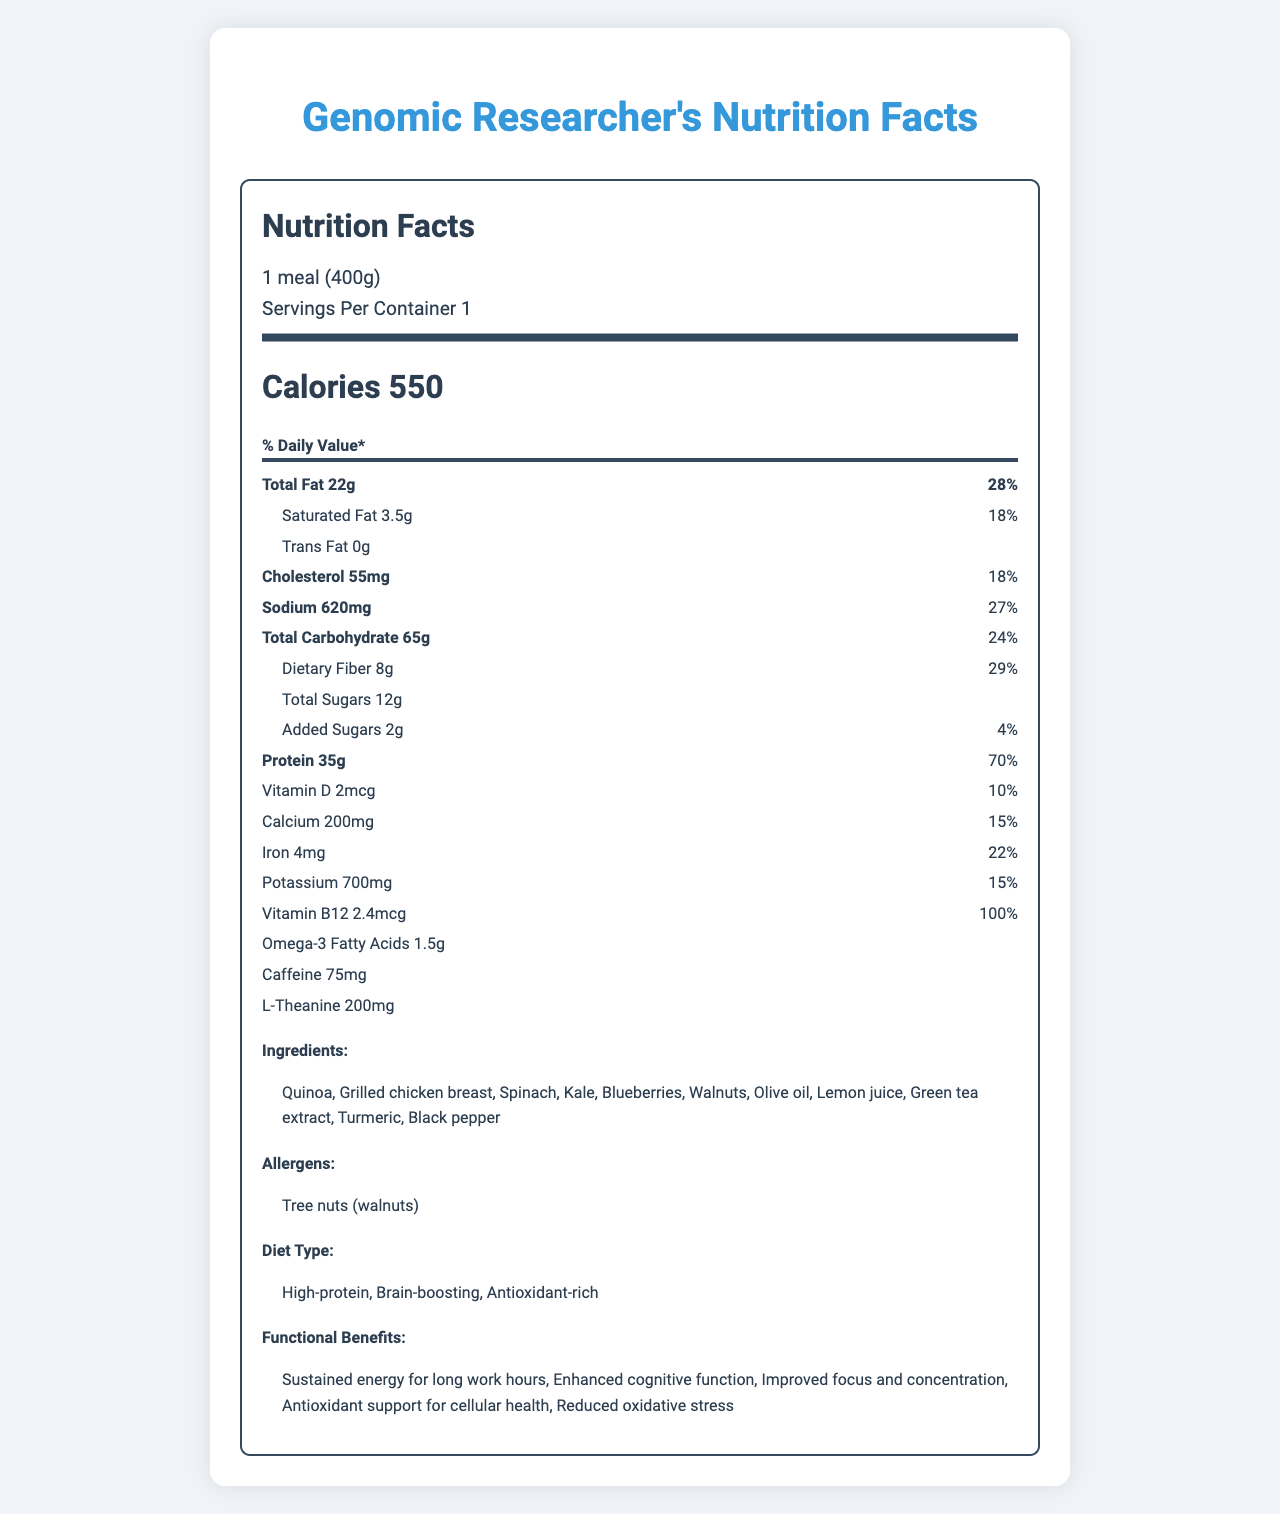what is the serving size? The serving size is stated at the top of the nutritional information section.
Answer: 1 meal (400g) how many calories are in one serving? The label clearly mentions that each serving contains 550 calories.
Answer: 550 what percentage of daily protein is provided by one serving? The protein section in the daily value column shows 70%.
Answer: 70% name one allergen listed on the label. The allergens section lists "Tree nuts (walnuts)" as an allergen.
Answer: Tree nuts (walnuts) which ingredient is the source of vitamin B12? The label does not specify which ingredient provides vitamin B12.
Answer: I don't know how many grams of dietary fiber are in this meal? The dietary fiber amount is listed under the total carbohydrate information.
Answer: 8g does the meal contain any trans fat? The label states that the trans fat amount is 0g.
Answer: No complete the percentage of daily value of calcium from the meal: 3, 10, 15, 20 The calcium daily value listed is 15%.
Answer: 15% what is the main functional benefit of this meal according to the label? One of the functional benefits listed is "Sustained energy for long work hours."
Answer: Sustained energy for long work hours which component has the highest daily value percentage: Cholesterol, Fiber, Vitamin B12, Potassium? A. Cholesterol B. Fiber C. Vitamin B12 D. Potassium Vitamin B12 has the highest daily value percentage with 100%.
Answer: C summarize the main idea of the document. The document provides comprehensive nutritional details of a meal tailored for enhancing cognitive function and sustaining energy for genomic researchers.
Answer: The document presents the nutritional information of a specialized diet plan designed for genomic researchers working long hours. It includes detailed nutrient content, ingredients, allergens, diet type, and functional benefits. what is the daily value percentage of sodium? The sodium daily value percentage is listed as 27%.
Answer: 27% list two ingredients that may contribute to the meal's antioxidant properties. Blueberries and Turmeric are known for their antioxidant properties and are listed in the ingredients.
Answer: Blueberries, Turmeric is this meal considered high-protein? The diet type section indicates that it is a high-protein meal.
Answer: Yes 